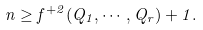<formula> <loc_0><loc_0><loc_500><loc_500>n \geq f ^ { + 2 } ( Q _ { 1 } , \cdots , Q _ { r } ) + 1 .</formula> 